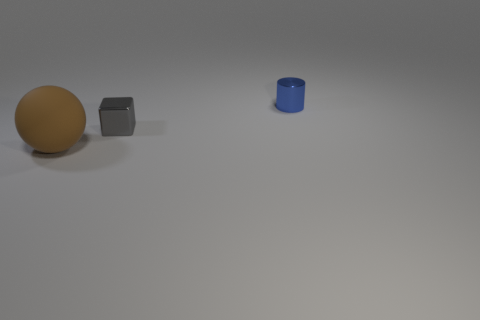How many small objects are shiny balls or gray shiny blocks?
Your response must be concise. 1. Are there more gray metallic cubes that are in front of the gray thing than small blue metallic cylinders in front of the large rubber ball?
Offer a very short reply. No. Does the small blue object have the same material as the tiny object in front of the tiny cylinder?
Provide a succinct answer. Yes. The small metallic cube has what color?
Your response must be concise. Gray. What is the shape of the small metal object that is right of the small gray thing?
Offer a very short reply. Cylinder. What number of green things are objects or big rubber spheres?
Your answer should be very brief. 0. What color is the tiny cube that is the same material as the cylinder?
Give a very brief answer. Gray. There is a tiny metal block; is its color the same as the rubber ball in front of the tiny cylinder?
Your answer should be very brief. No. There is a thing that is in front of the tiny blue metallic cylinder and behind the large brown object; what color is it?
Your answer should be very brief. Gray. What number of blue cylinders are left of the gray cube?
Make the answer very short. 0. 